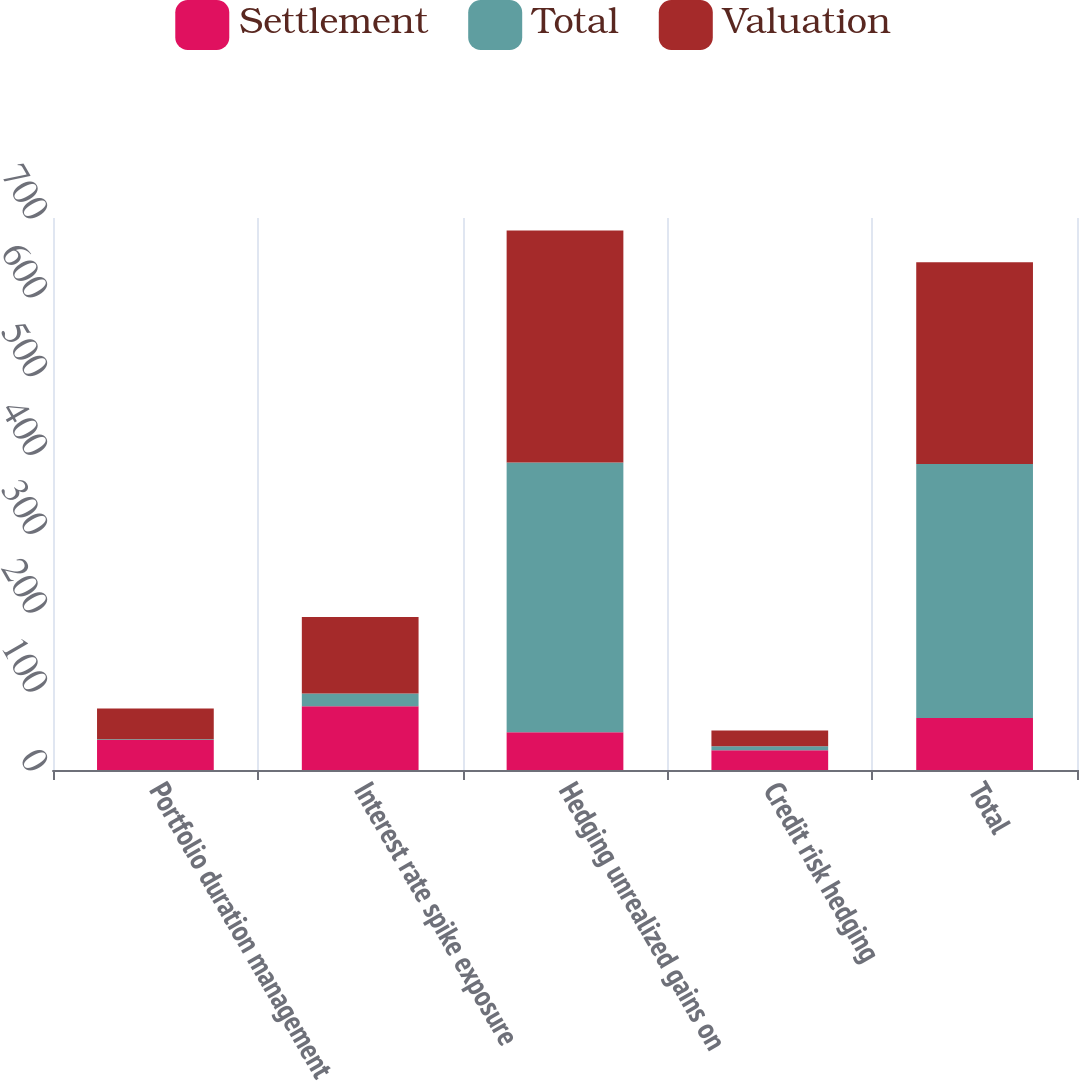Convert chart. <chart><loc_0><loc_0><loc_500><loc_500><stacked_bar_chart><ecel><fcel>Portfolio duration management<fcel>Interest rate spike exposure<fcel>Hedging unrealized gains on<fcel>Credit risk hedging<fcel>Total<nl><fcel>Settlement<fcel>38<fcel>81<fcel>48<fcel>25<fcel>66<nl><fcel>Total<fcel>1<fcel>16<fcel>342<fcel>5<fcel>322<nl><fcel>Valuation<fcel>39<fcel>97<fcel>294<fcel>20<fcel>256<nl></chart> 